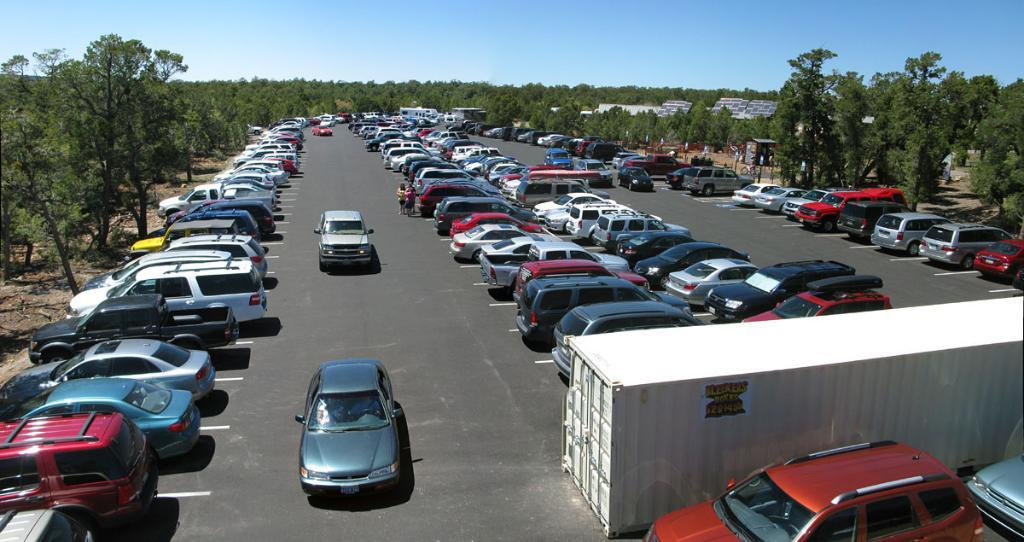What can be seen on the road in the image? There are cars on the road in the image. What is the container with a poster on it used for? The container with a poster on it is not specified in the image, but it could be used for storage or display purposes. What type of structures are visible in the image? There are buildings in the image. What other natural elements can be seen in the image? There are trees in the image. What are the boards in the image used for? The boards in the image could be used for signage, advertisements, or construction purposes. What is visible at the top of the image? The sky is visible at the top of the image. Can you see any fowl perched on the boards in the image? There is no mention of fowl in the image, so it cannot be determined if any are present. Are there any cobwebs visible on the buildings in the image? There is no mention of cobwebs in the image, so it cannot be determined if any are present. 